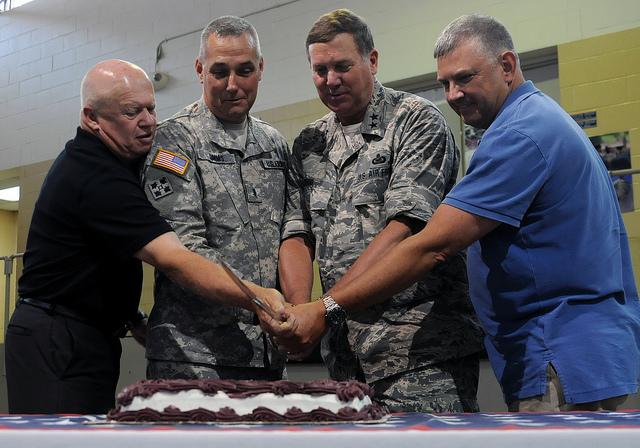Where is the sword in this picture?
Be succinct. Above cake. Is this a party?
Quick response, please. Yes. How many candles are there?
Be succinct. 0. How many men?
Keep it brief. 4. What are the two men in the middle wearing?
Quick response, please. Uniforms. 